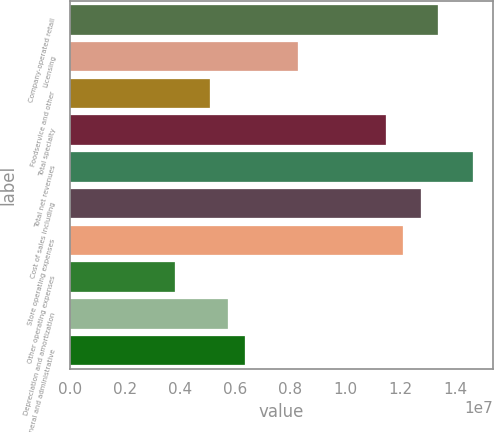<chart> <loc_0><loc_0><loc_500><loc_500><bar_chart><fcel>Company-operated retail<fcel>Licensing<fcel>Foodservice and other<fcel>Total specialty<fcel>Total net revenues<fcel>Cost of sales including<fcel>Store operating expenses<fcel>Other operating expenses<fcel>Depreciation and amortization<fcel>General and administrative<nl><fcel>1.33755e+07<fcel>8.28009e+06<fcel>5.09544e+06<fcel>1.14647e+07<fcel>1.46494e+07<fcel>1.27386e+07<fcel>1.21017e+07<fcel>3.82158e+06<fcel>5.73237e+06<fcel>6.3693e+06<nl></chart> 